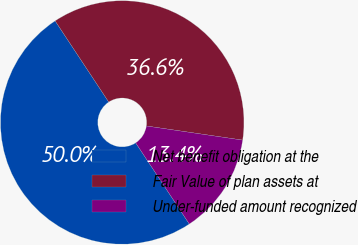Convert chart. <chart><loc_0><loc_0><loc_500><loc_500><pie_chart><fcel>Net benefit obligation at the<fcel>Fair Value of plan assets at<fcel>Under-funded amount recognized<nl><fcel>50.0%<fcel>36.61%<fcel>13.39%<nl></chart> 